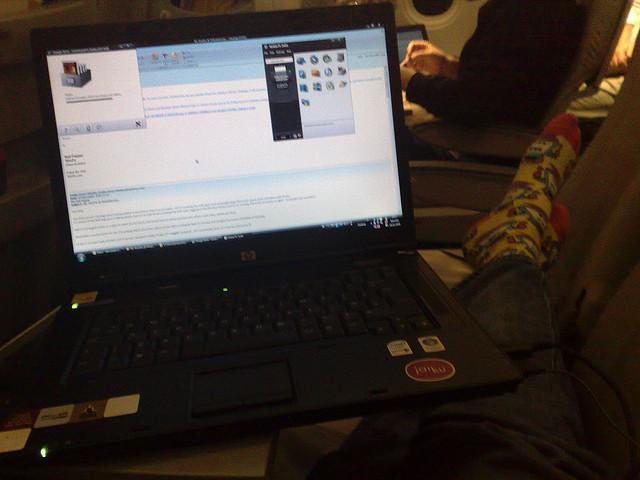This person is operating their laptop in what form of transportation?
Pick the correct solution from the four options below to address the question.
Options: Bus, train, plane, car. Plane. 